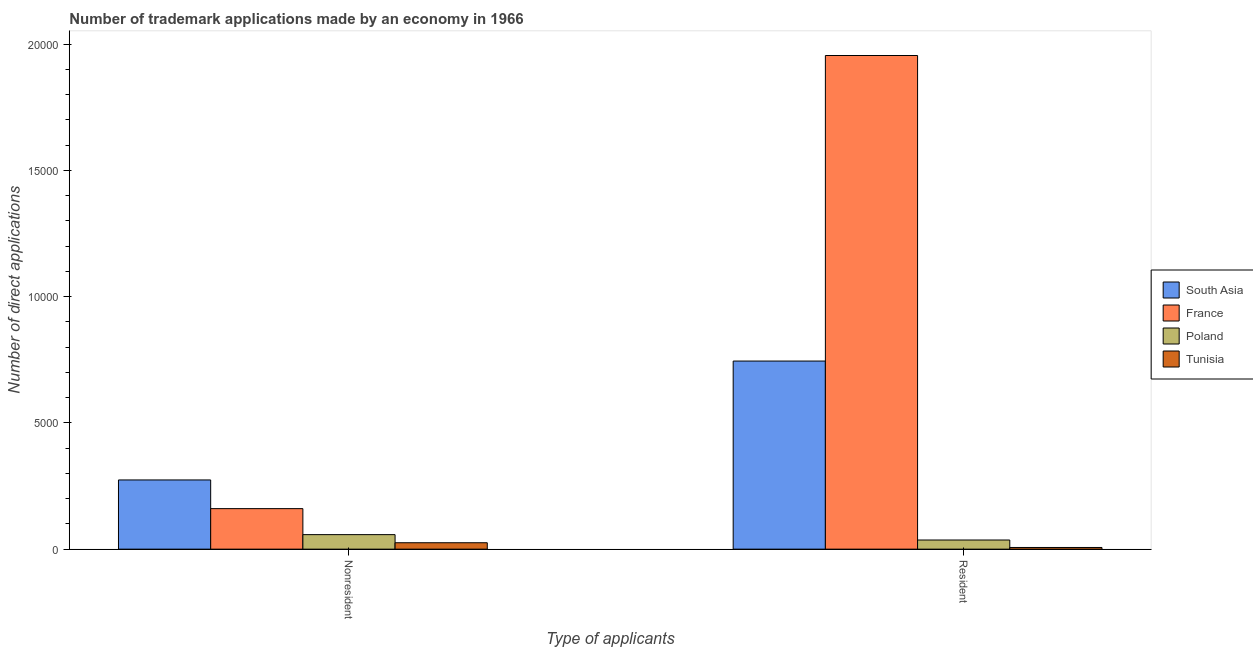Are the number of bars per tick equal to the number of legend labels?
Keep it short and to the point. Yes. Are the number of bars on each tick of the X-axis equal?
Keep it short and to the point. Yes. How many bars are there on the 1st tick from the left?
Your answer should be compact. 4. What is the label of the 2nd group of bars from the left?
Offer a terse response. Resident. What is the number of trademark applications made by residents in South Asia?
Your answer should be very brief. 7450. Across all countries, what is the maximum number of trademark applications made by non residents?
Keep it short and to the point. 2741. Across all countries, what is the minimum number of trademark applications made by residents?
Make the answer very short. 66. In which country was the number of trademark applications made by non residents maximum?
Your answer should be compact. South Asia. In which country was the number of trademark applications made by residents minimum?
Ensure brevity in your answer.  Tunisia. What is the total number of trademark applications made by non residents in the graph?
Keep it short and to the point. 5175. What is the difference between the number of trademark applications made by non residents in South Asia and that in Poland?
Offer a very short reply. 2166. What is the difference between the number of trademark applications made by non residents in France and the number of trademark applications made by residents in Poland?
Your answer should be very brief. 1243. What is the average number of trademark applications made by non residents per country?
Make the answer very short. 1293.75. What is the difference between the number of trademark applications made by non residents and number of trademark applications made by residents in France?
Your answer should be very brief. -1.79e+04. What is the ratio of the number of trademark applications made by non residents in Poland to that in South Asia?
Give a very brief answer. 0.21. In how many countries, is the number of trademark applications made by residents greater than the average number of trademark applications made by residents taken over all countries?
Offer a very short reply. 2. What does the 3rd bar from the left in Resident represents?
Provide a succinct answer. Poland. How many bars are there?
Ensure brevity in your answer.  8. Are all the bars in the graph horizontal?
Keep it short and to the point. No. What is the difference between two consecutive major ticks on the Y-axis?
Make the answer very short. 5000. Are the values on the major ticks of Y-axis written in scientific E-notation?
Your response must be concise. No. Does the graph contain grids?
Your response must be concise. No. Where does the legend appear in the graph?
Provide a succinct answer. Center right. How are the legend labels stacked?
Keep it short and to the point. Vertical. What is the title of the graph?
Your response must be concise. Number of trademark applications made by an economy in 1966. Does "Aruba" appear as one of the legend labels in the graph?
Your answer should be compact. No. What is the label or title of the X-axis?
Your answer should be compact. Type of applicants. What is the label or title of the Y-axis?
Make the answer very short. Number of direct applications. What is the Number of direct applications of South Asia in Nonresident?
Your answer should be compact. 2741. What is the Number of direct applications of France in Nonresident?
Provide a succinct answer. 1605. What is the Number of direct applications of Poland in Nonresident?
Make the answer very short. 575. What is the Number of direct applications of Tunisia in Nonresident?
Offer a very short reply. 254. What is the Number of direct applications in South Asia in Resident?
Your answer should be very brief. 7450. What is the Number of direct applications of France in Resident?
Keep it short and to the point. 1.96e+04. What is the Number of direct applications of Poland in Resident?
Offer a terse response. 362. What is the Number of direct applications of Tunisia in Resident?
Provide a short and direct response. 66. Across all Type of applicants, what is the maximum Number of direct applications in South Asia?
Your answer should be very brief. 7450. Across all Type of applicants, what is the maximum Number of direct applications in France?
Give a very brief answer. 1.96e+04. Across all Type of applicants, what is the maximum Number of direct applications in Poland?
Your answer should be very brief. 575. Across all Type of applicants, what is the maximum Number of direct applications of Tunisia?
Your response must be concise. 254. Across all Type of applicants, what is the minimum Number of direct applications in South Asia?
Your answer should be compact. 2741. Across all Type of applicants, what is the minimum Number of direct applications of France?
Provide a short and direct response. 1605. Across all Type of applicants, what is the minimum Number of direct applications of Poland?
Provide a short and direct response. 362. Across all Type of applicants, what is the minimum Number of direct applications of Tunisia?
Provide a short and direct response. 66. What is the total Number of direct applications of South Asia in the graph?
Make the answer very short. 1.02e+04. What is the total Number of direct applications in France in the graph?
Make the answer very short. 2.12e+04. What is the total Number of direct applications in Poland in the graph?
Keep it short and to the point. 937. What is the total Number of direct applications of Tunisia in the graph?
Your response must be concise. 320. What is the difference between the Number of direct applications in South Asia in Nonresident and that in Resident?
Offer a very short reply. -4709. What is the difference between the Number of direct applications in France in Nonresident and that in Resident?
Offer a terse response. -1.79e+04. What is the difference between the Number of direct applications of Poland in Nonresident and that in Resident?
Offer a terse response. 213. What is the difference between the Number of direct applications in Tunisia in Nonresident and that in Resident?
Ensure brevity in your answer.  188. What is the difference between the Number of direct applications of South Asia in Nonresident and the Number of direct applications of France in Resident?
Provide a short and direct response. -1.68e+04. What is the difference between the Number of direct applications of South Asia in Nonresident and the Number of direct applications of Poland in Resident?
Provide a succinct answer. 2379. What is the difference between the Number of direct applications in South Asia in Nonresident and the Number of direct applications in Tunisia in Resident?
Your answer should be very brief. 2675. What is the difference between the Number of direct applications in France in Nonresident and the Number of direct applications in Poland in Resident?
Ensure brevity in your answer.  1243. What is the difference between the Number of direct applications in France in Nonresident and the Number of direct applications in Tunisia in Resident?
Your answer should be very brief. 1539. What is the difference between the Number of direct applications of Poland in Nonresident and the Number of direct applications of Tunisia in Resident?
Provide a succinct answer. 509. What is the average Number of direct applications in South Asia per Type of applicants?
Provide a succinct answer. 5095.5. What is the average Number of direct applications in France per Type of applicants?
Make the answer very short. 1.06e+04. What is the average Number of direct applications in Poland per Type of applicants?
Provide a short and direct response. 468.5. What is the average Number of direct applications of Tunisia per Type of applicants?
Offer a very short reply. 160. What is the difference between the Number of direct applications of South Asia and Number of direct applications of France in Nonresident?
Ensure brevity in your answer.  1136. What is the difference between the Number of direct applications of South Asia and Number of direct applications of Poland in Nonresident?
Offer a very short reply. 2166. What is the difference between the Number of direct applications in South Asia and Number of direct applications in Tunisia in Nonresident?
Offer a very short reply. 2487. What is the difference between the Number of direct applications of France and Number of direct applications of Poland in Nonresident?
Provide a short and direct response. 1030. What is the difference between the Number of direct applications of France and Number of direct applications of Tunisia in Nonresident?
Give a very brief answer. 1351. What is the difference between the Number of direct applications in Poland and Number of direct applications in Tunisia in Nonresident?
Offer a very short reply. 321. What is the difference between the Number of direct applications in South Asia and Number of direct applications in France in Resident?
Provide a short and direct response. -1.21e+04. What is the difference between the Number of direct applications of South Asia and Number of direct applications of Poland in Resident?
Your answer should be very brief. 7088. What is the difference between the Number of direct applications of South Asia and Number of direct applications of Tunisia in Resident?
Provide a short and direct response. 7384. What is the difference between the Number of direct applications in France and Number of direct applications in Poland in Resident?
Your answer should be compact. 1.92e+04. What is the difference between the Number of direct applications of France and Number of direct applications of Tunisia in Resident?
Offer a terse response. 1.95e+04. What is the difference between the Number of direct applications in Poland and Number of direct applications in Tunisia in Resident?
Your response must be concise. 296. What is the ratio of the Number of direct applications of South Asia in Nonresident to that in Resident?
Your answer should be compact. 0.37. What is the ratio of the Number of direct applications of France in Nonresident to that in Resident?
Provide a short and direct response. 0.08. What is the ratio of the Number of direct applications in Poland in Nonresident to that in Resident?
Provide a short and direct response. 1.59. What is the ratio of the Number of direct applications of Tunisia in Nonresident to that in Resident?
Your answer should be very brief. 3.85. What is the difference between the highest and the second highest Number of direct applications in South Asia?
Offer a very short reply. 4709. What is the difference between the highest and the second highest Number of direct applications of France?
Your response must be concise. 1.79e+04. What is the difference between the highest and the second highest Number of direct applications of Poland?
Provide a short and direct response. 213. What is the difference between the highest and the second highest Number of direct applications in Tunisia?
Offer a terse response. 188. What is the difference between the highest and the lowest Number of direct applications in South Asia?
Your answer should be compact. 4709. What is the difference between the highest and the lowest Number of direct applications of France?
Provide a short and direct response. 1.79e+04. What is the difference between the highest and the lowest Number of direct applications of Poland?
Ensure brevity in your answer.  213. What is the difference between the highest and the lowest Number of direct applications in Tunisia?
Your answer should be very brief. 188. 